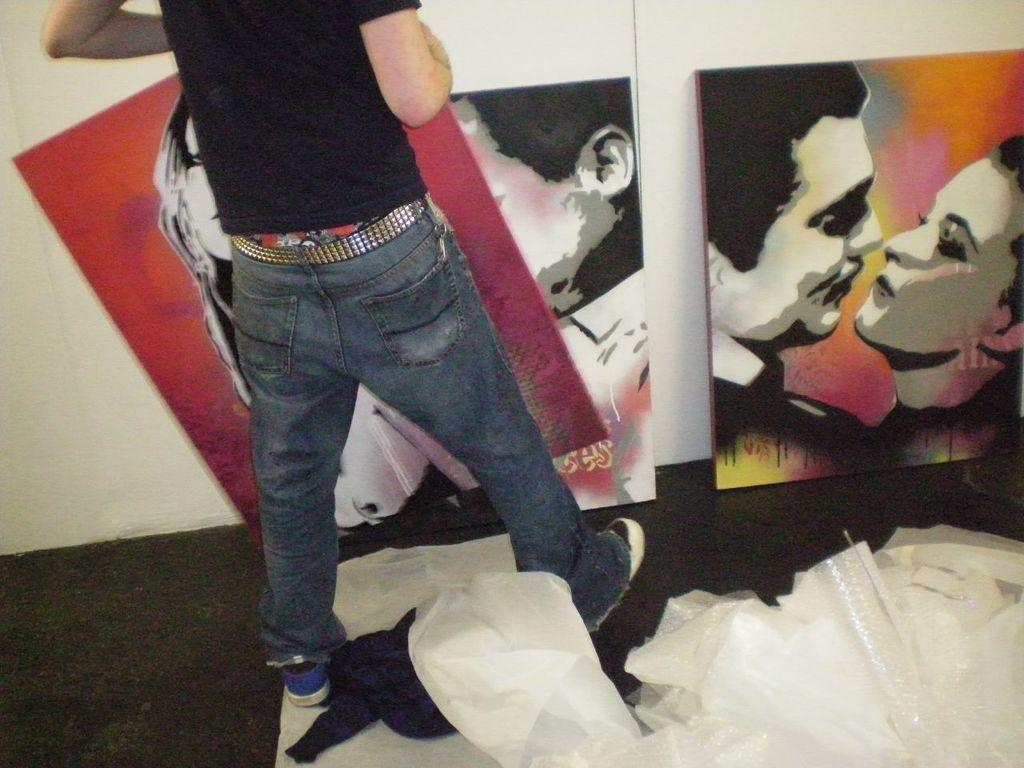Who or what is present in the image? There is a person in the image. What is in front of the person? There are posters in front of the person. What else can be seen in the image? There are bags visible in the image. What type of pipe is being used by the secretary in the image? There is no secretary or pipe present in the image. 